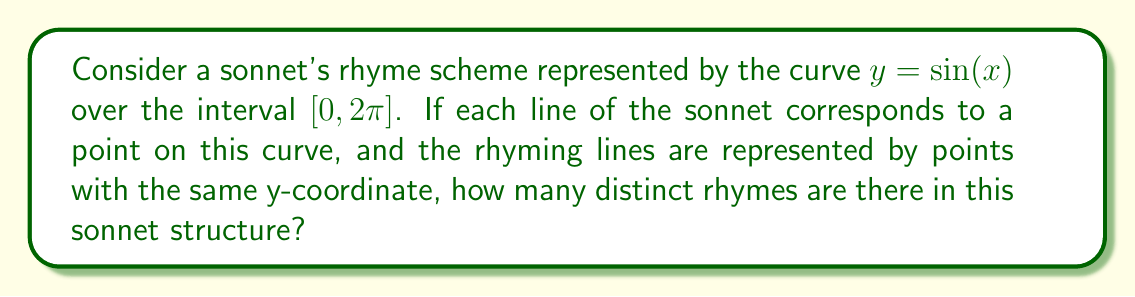Can you solve this math problem? Let's approach this step-by-step:

1) The curve $y = \sin(x)$ over $[0, 2\pi]$ completes one full cycle.

2) A sonnet typically has 14 lines. We need to divide the interval $[0, 2\pi]$ into 14 equal parts.

3) The x-coordinates of these points will be:
   $x_k = \frac{2\pi k}{14}$, where $k = 0, 1, 2, ..., 13$

4) The y-coordinates (representing the rhymes) will be:
   $y_k = \sin(\frac{2\pi k}{14})$

5) Due to the symmetry of the sine function:
   $\sin(x) = \sin(\pi - x)$

6) This means that in the first half of the cycle (first 7 points), each y-value will have a corresponding equal value in the second half, except for the first and last points.

7) The first point $(0, \sin(0))$ and the middle point $(\pi, \sin(\pi))$ are unique as they represent $y = 0$.

8) Therefore, we have:
   - 2 unique points (start and middle)
   - 6 pairs of matching points

9) Each pair of matching points represents a rhyme, and the two unique points represent their own rhymes.

Thus, we have 6 + 2 = 8 distinct rhymes in this sonnet structure.

[asy]
import graph;
size(200,200);
real f(real x) {return sin(x);}
draw(graph(f,0,2pi));
for(int i=0; i<14; ++i) {
  dot((2pi*i/14, sin(2pi*i/14)));
}
xaxis("x");
yaxis("y");
[/asy]
Answer: 8 